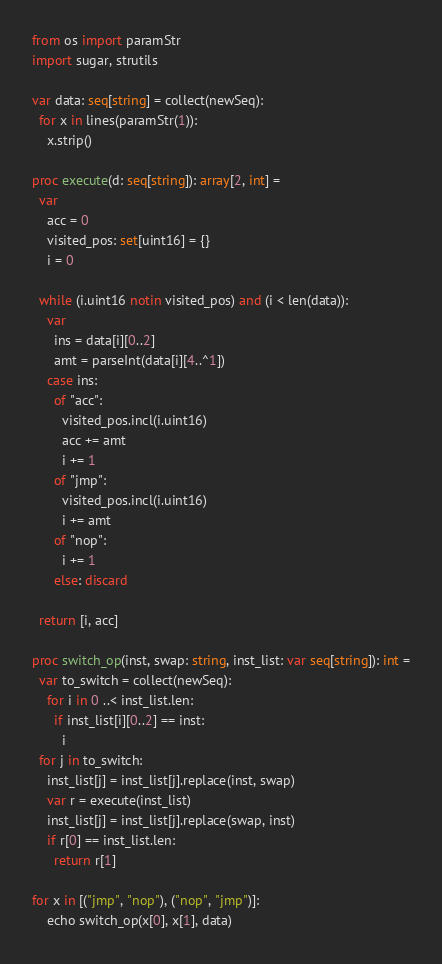Convert code to text. <code><loc_0><loc_0><loc_500><loc_500><_Nim_>from os import paramStr
import sugar, strutils

var data: seq[string] = collect(newSeq):
  for x in lines(paramStr(1)):
    x.strip()

proc execute(d: seq[string]): array[2, int] = 
  var
    acc = 0
    visited_pos: set[uint16] = {}
    i = 0

  while (i.uint16 notin visited_pos) and (i < len(data)):
    var
      ins = data[i][0..2]
      amt = parseInt(data[i][4..^1])
    case ins:
      of "acc":
        visited_pos.incl(i.uint16)
        acc += amt
        i += 1
      of "jmp":
        visited_pos.incl(i.uint16)
        i += amt
      of "nop":
        i += 1
      else: discard

  return [i, acc]

proc switch_op(inst, swap: string, inst_list: var seq[string]): int =
  var to_switch = collect(newSeq):
    for i in 0 ..< inst_list.len:
      if inst_list[i][0..2] == inst:
        i
  for j in to_switch:
    inst_list[j] = inst_list[j].replace(inst, swap)    
    var r = execute(inst_list)
    inst_list[j] = inst_list[j].replace(swap, inst)  
    if r[0] == inst_list.len:
      return r[1]

for x in [("jmp", "nop"), ("nop", "jmp")]:
    echo switch_op(x[0], x[1], data)
</code> 